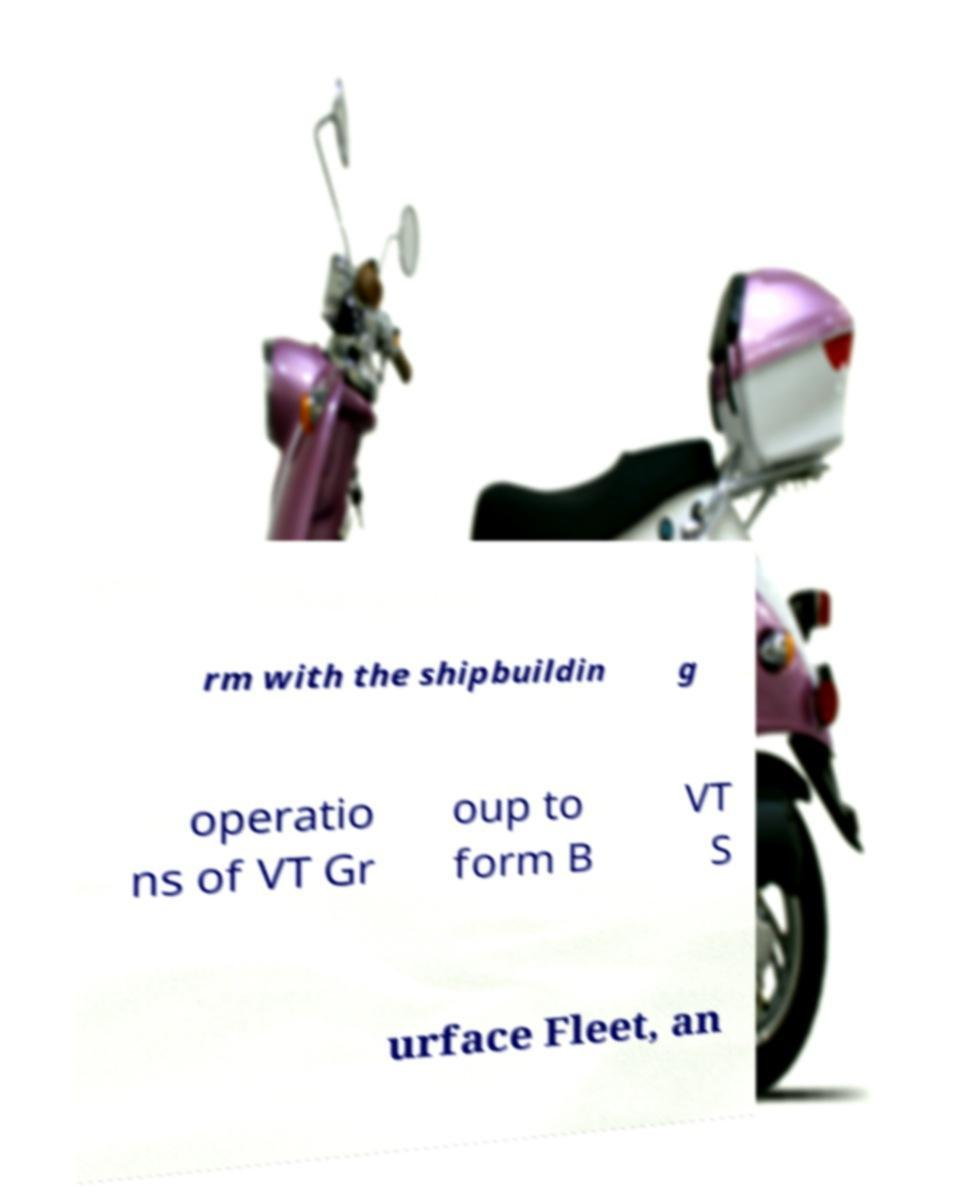Please read and relay the text visible in this image. What does it say? rm with the shipbuildin g operatio ns of VT Gr oup to form B VT S urface Fleet, an 